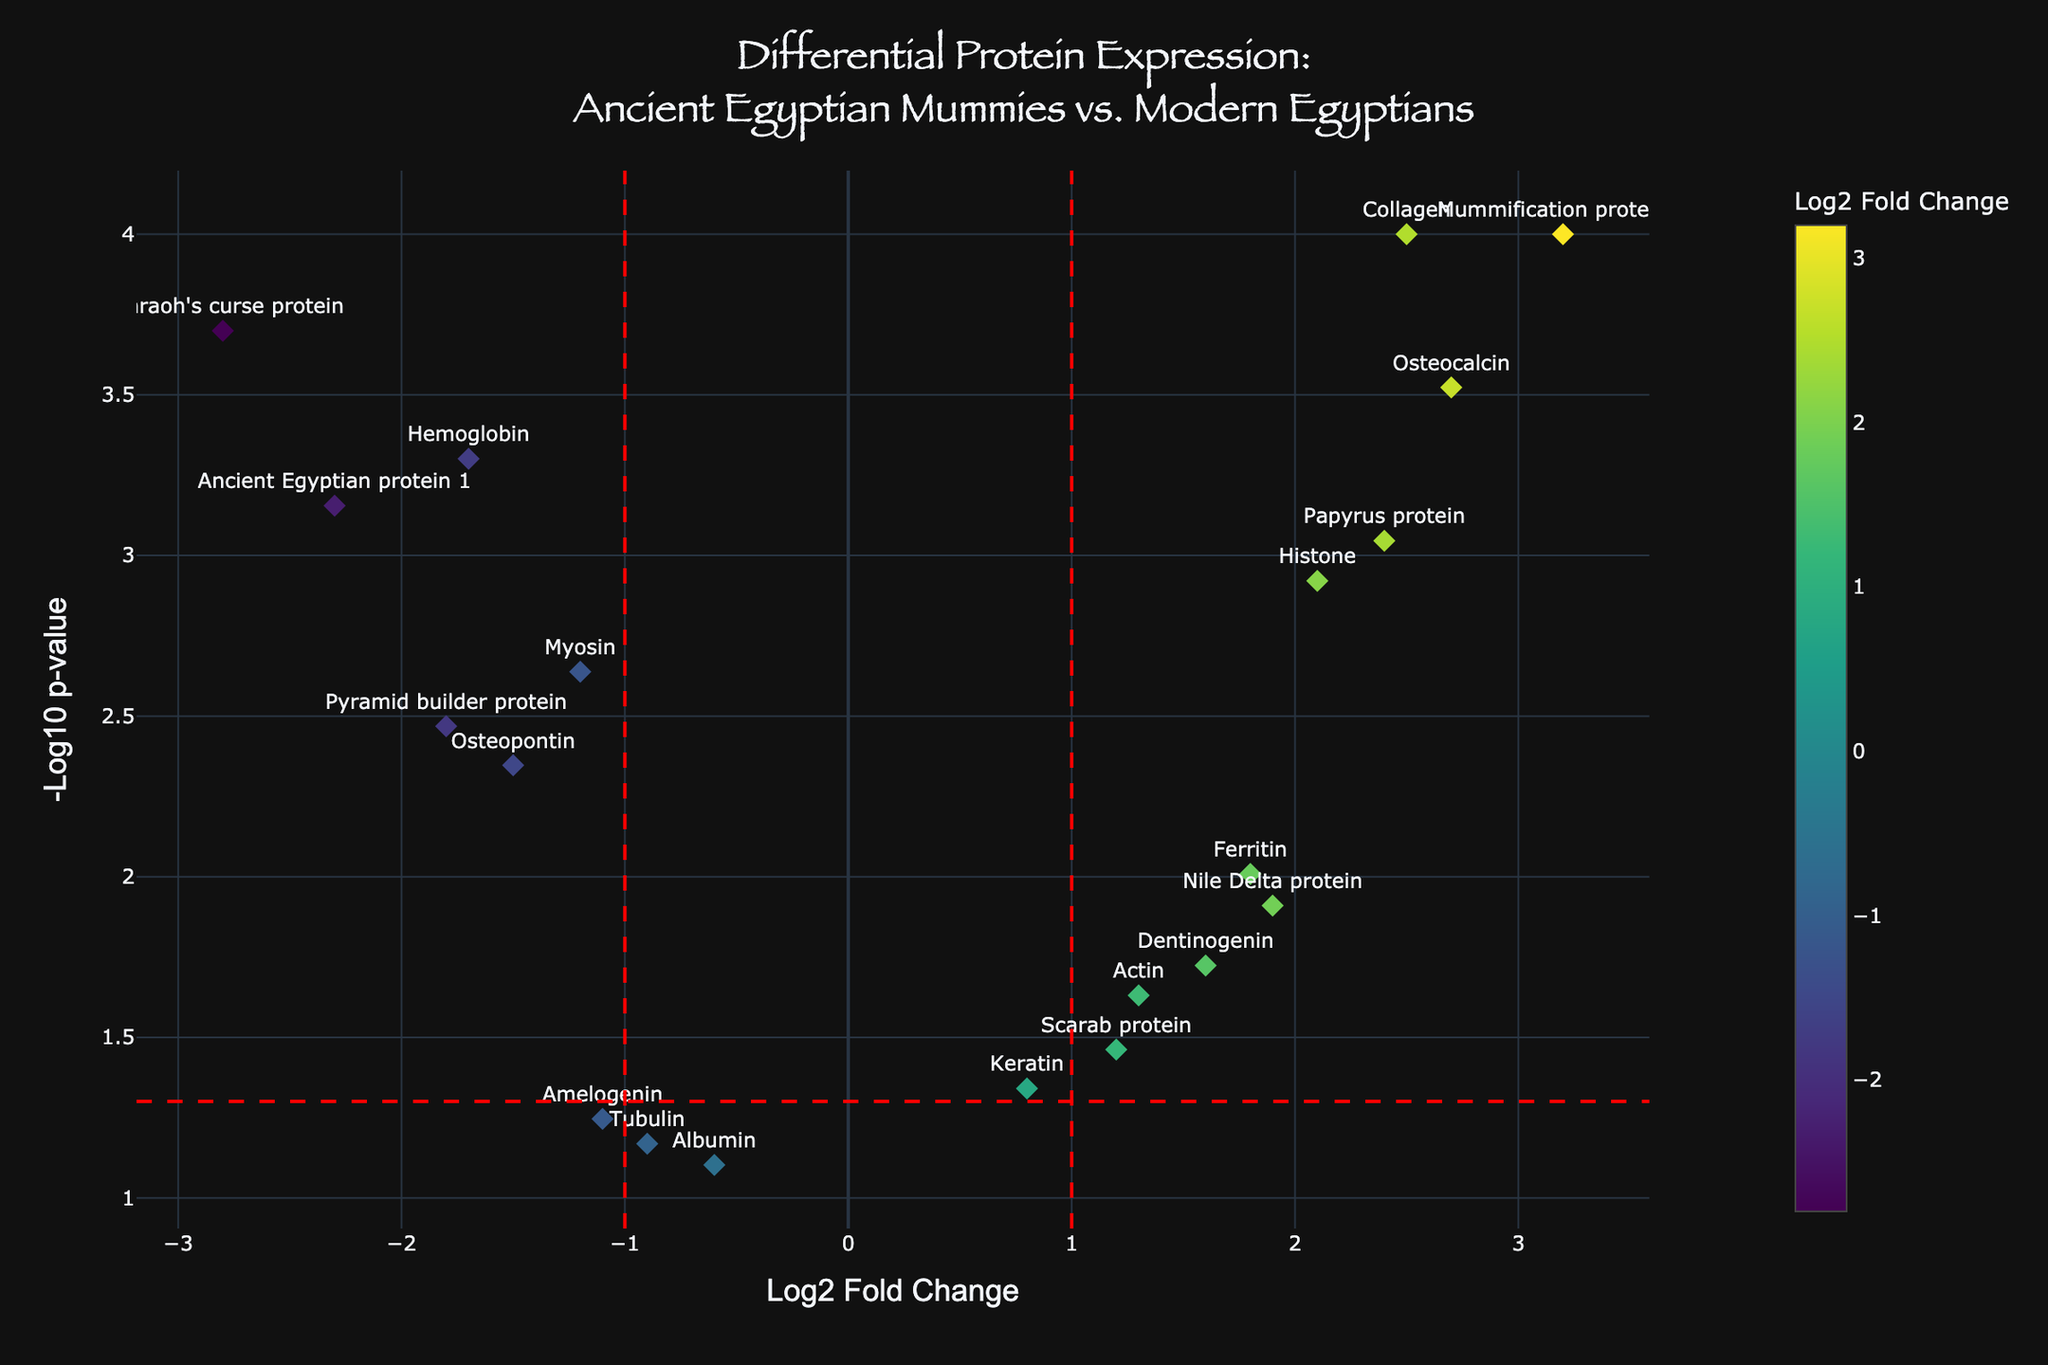How many proteins are listed in the figure? To find the number of proteins, we need to count the data points labeled with protein names. By examining the figure, we see there are 20 labeled data points, each representing a different protein.
Answer: 20 What is the title of the figure? The title is prominently displayed at the top of the plot. It reads, "Differential Protein Expression: Ancient Egyptian Mummies vs. Modern Egyptians."
Answer: Differential Protein Expression: Ancient Egyptian Mummies vs. Modern Egyptians Which protein has the highest log2 fold change? To find this, we look for the data point with the highest x-axis value. "Mummification protein A" has the highest log2 fold change value of 3.2.
Answer: Mummification protein A Which protein has the lowest p-value? The p-value is represented on the y-axis as -log10(p-value); a lower p-value means a higher -log10(p-value). "Collagen" and "Mummification protein A" both have the highest -log10(p-value), corresponding to the smallest p-value of 0.0001.
Answer: Collagen and Mummification protein A How many proteins have a log2 fold change greater than 1? We need to count data points with log2 fold change values greater than 1. There are seven such proteins: "Collagen," "Actin," "Histone," "Ferritin," "Osteocalcin," "Dentinogenin," "Mummification protein A," "Nile Delta protein," "Papyrus protein," and "Scarab protein."
Answer: 10 Which proteins have log2 fold changes between -1 and 1 and a p-value less than 0.05? We filter the data points within the range of -1 to 1 on the x-axis and y-axis values above the -log10(p-value) threshold line of approximately 1.301 (corresponding to p = 0.05). The proteins are "Keratin," "Actin," and "Scarab protein."
Answer: Keratin, Actin, Scarab protein Are there more upregulated or downregulated proteins? Upregulated proteins have positive log2 fold changes, while downregulated proteins have negative values. By counting, we have 11 upregulated (positive log2 FC) and 9 downregulated (negative log2 FC) proteins.
Answer: More upregulated Which protein has the second-highest -log10(p-value)? The second-highest -log10(p-value) corresponds to the second-highest y-axis value. "Pharaoh's curse protein" has the second-highest -log10(p-value) due to its p-value of 0.0002.
Answer: Pharaoh's curse protein What is the log2 fold change and p-value of "Ancient Egyptian protein 1"? By hovering over the data point labeled "Ancient Egyptian protein 1," we see that its log2 fold change is -2.3 and its p-value is 0.0007.
Answer: -2.3 and 0.0007 How many proteins are statistically significant according to the plot? A protein is considered statistically significant if its data point is above the horizontal red line (-log10(p-value) > 1.301). By examining the plot, there are 13 proteins above this threshold.
Answer: 13 